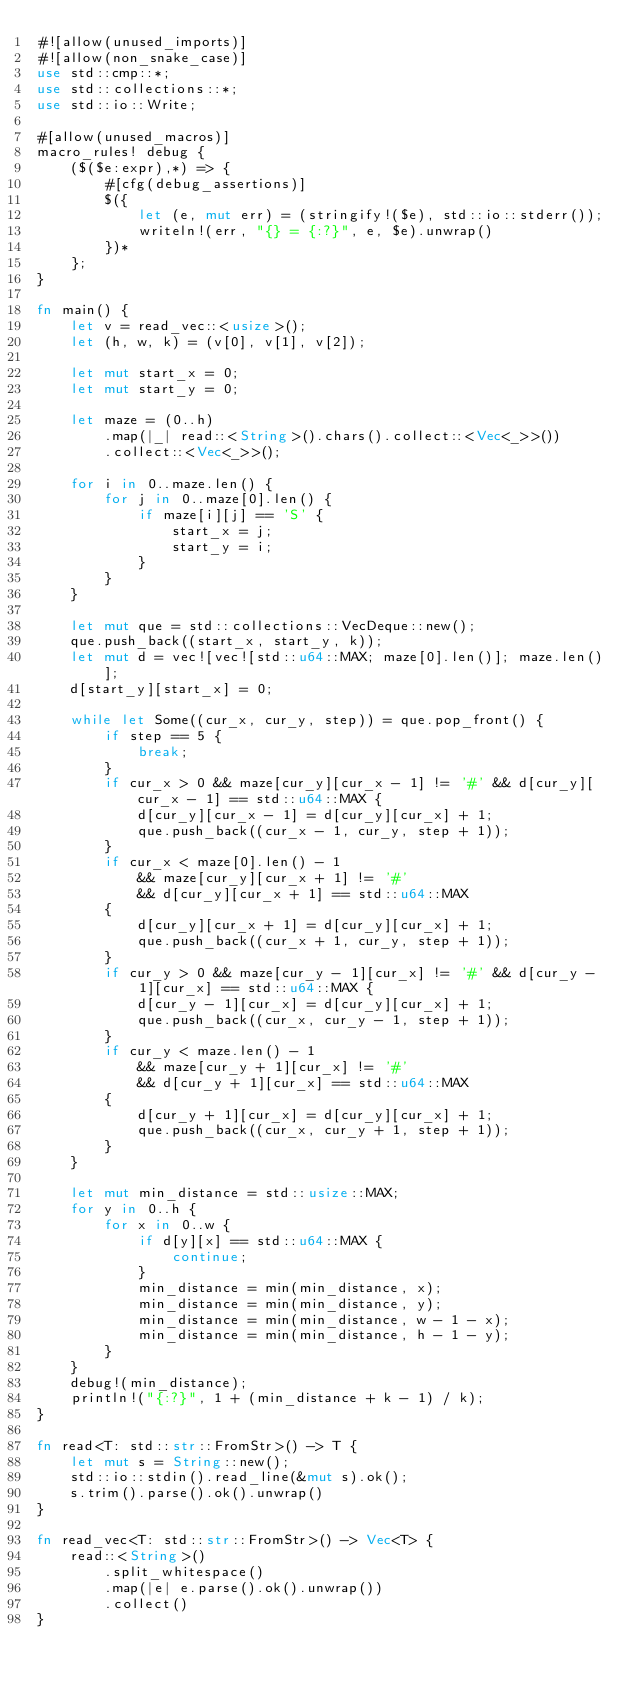<code> <loc_0><loc_0><loc_500><loc_500><_Rust_>#![allow(unused_imports)]
#![allow(non_snake_case)]
use std::cmp::*;
use std::collections::*;
use std::io::Write;

#[allow(unused_macros)]
macro_rules! debug {
    ($($e:expr),*) => {
        #[cfg(debug_assertions)]
        $({
            let (e, mut err) = (stringify!($e), std::io::stderr());
            writeln!(err, "{} = {:?}", e, $e).unwrap()
        })*
    };
}

fn main() {
    let v = read_vec::<usize>();
    let (h, w, k) = (v[0], v[1], v[2]);

    let mut start_x = 0;
    let mut start_y = 0;

    let maze = (0..h)
        .map(|_| read::<String>().chars().collect::<Vec<_>>())
        .collect::<Vec<_>>();

    for i in 0..maze.len() {
        for j in 0..maze[0].len() {
            if maze[i][j] == 'S' {
                start_x = j;
                start_y = i;
            }
        }
    }

    let mut que = std::collections::VecDeque::new();
    que.push_back((start_x, start_y, k));
    let mut d = vec![vec![std::u64::MAX; maze[0].len()]; maze.len()];
    d[start_y][start_x] = 0;

    while let Some((cur_x, cur_y, step)) = que.pop_front() {
        if step == 5 {
            break;
        }
        if cur_x > 0 && maze[cur_y][cur_x - 1] != '#' && d[cur_y][cur_x - 1] == std::u64::MAX {
            d[cur_y][cur_x - 1] = d[cur_y][cur_x] + 1;
            que.push_back((cur_x - 1, cur_y, step + 1));
        }
        if cur_x < maze[0].len() - 1
            && maze[cur_y][cur_x + 1] != '#'
            && d[cur_y][cur_x + 1] == std::u64::MAX
        {
            d[cur_y][cur_x + 1] = d[cur_y][cur_x] + 1;
            que.push_back((cur_x + 1, cur_y, step + 1));
        }
        if cur_y > 0 && maze[cur_y - 1][cur_x] != '#' && d[cur_y - 1][cur_x] == std::u64::MAX {
            d[cur_y - 1][cur_x] = d[cur_y][cur_x] + 1;
            que.push_back((cur_x, cur_y - 1, step + 1));
        }
        if cur_y < maze.len() - 1
            && maze[cur_y + 1][cur_x] != '#'
            && d[cur_y + 1][cur_x] == std::u64::MAX
        {
            d[cur_y + 1][cur_x] = d[cur_y][cur_x] + 1;
            que.push_back((cur_x, cur_y + 1, step + 1));
        }
    }

    let mut min_distance = std::usize::MAX;
    for y in 0..h {
        for x in 0..w {
            if d[y][x] == std::u64::MAX {
                continue;
            }
            min_distance = min(min_distance, x);
            min_distance = min(min_distance, y);
            min_distance = min(min_distance, w - 1 - x);
            min_distance = min(min_distance, h - 1 - y);
        }
    }
    debug!(min_distance);
    println!("{:?}", 1 + (min_distance + k - 1) / k);
}

fn read<T: std::str::FromStr>() -> T {
    let mut s = String::new();
    std::io::stdin().read_line(&mut s).ok();
    s.trim().parse().ok().unwrap()
}

fn read_vec<T: std::str::FromStr>() -> Vec<T> {
    read::<String>()
        .split_whitespace()
        .map(|e| e.parse().ok().unwrap())
        .collect()
}
</code> 